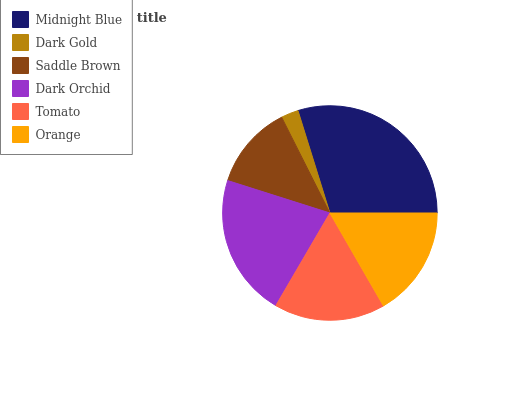Is Dark Gold the minimum?
Answer yes or no. Yes. Is Midnight Blue the maximum?
Answer yes or no. Yes. Is Saddle Brown the minimum?
Answer yes or no. No. Is Saddle Brown the maximum?
Answer yes or no. No. Is Saddle Brown greater than Dark Gold?
Answer yes or no. Yes. Is Dark Gold less than Saddle Brown?
Answer yes or no. Yes. Is Dark Gold greater than Saddle Brown?
Answer yes or no. No. Is Saddle Brown less than Dark Gold?
Answer yes or no. No. Is Tomato the high median?
Answer yes or no. Yes. Is Orange the low median?
Answer yes or no. Yes. Is Dark Gold the high median?
Answer yes or no. No. Is Saddle Brown the low median?
Answer yes or no. No. 